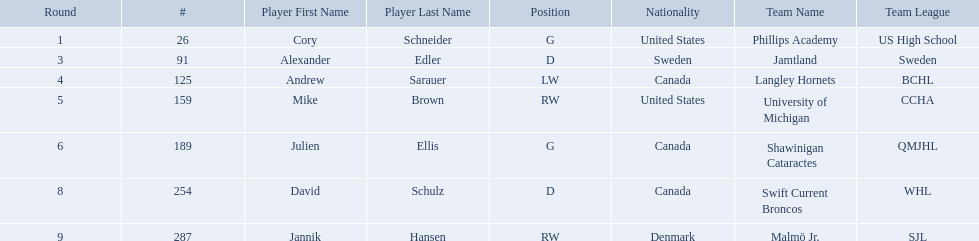Who are the players? Cory Schneider (G), Alexander Edler (D), Andrew Sarauer (LW), Mike Brown (RW), Julien Ellis (G), David Schulz (D), Jannik Hansen (RW). Of those, who is from denmark? Jannik Hansen (RW). Who were the players in the 2004-05 vancouver canucks season Cory Schneider (G), Alexander Edler (D), Andrew Sarauer (LW), Mike Brown (RW), Julien Ellis (G), David Schulz (D), Jannik Hansen (RW). Of these players who had a nationality of denmark? Jannik Hansen (RW). What are the names of the colleges and jr leagues the players attended? Phillips Academy (US High School), Jamtland (Sweden), Langley Hornets (BCHL), University of Michigan (CCHA), Shawinigan Cataractes (QMJHL), Swift Current Broncos (WHL), Malmö Jr. (SJL). Which player played for the langley hornets? Andrew Sarauer (LW). Which players have canadian nationality? Andrew Sarauer (LW), Julien Ellis (G), David Schulz (D). Of those, which attended langley hornets? Andrew Sarauer (LW). 